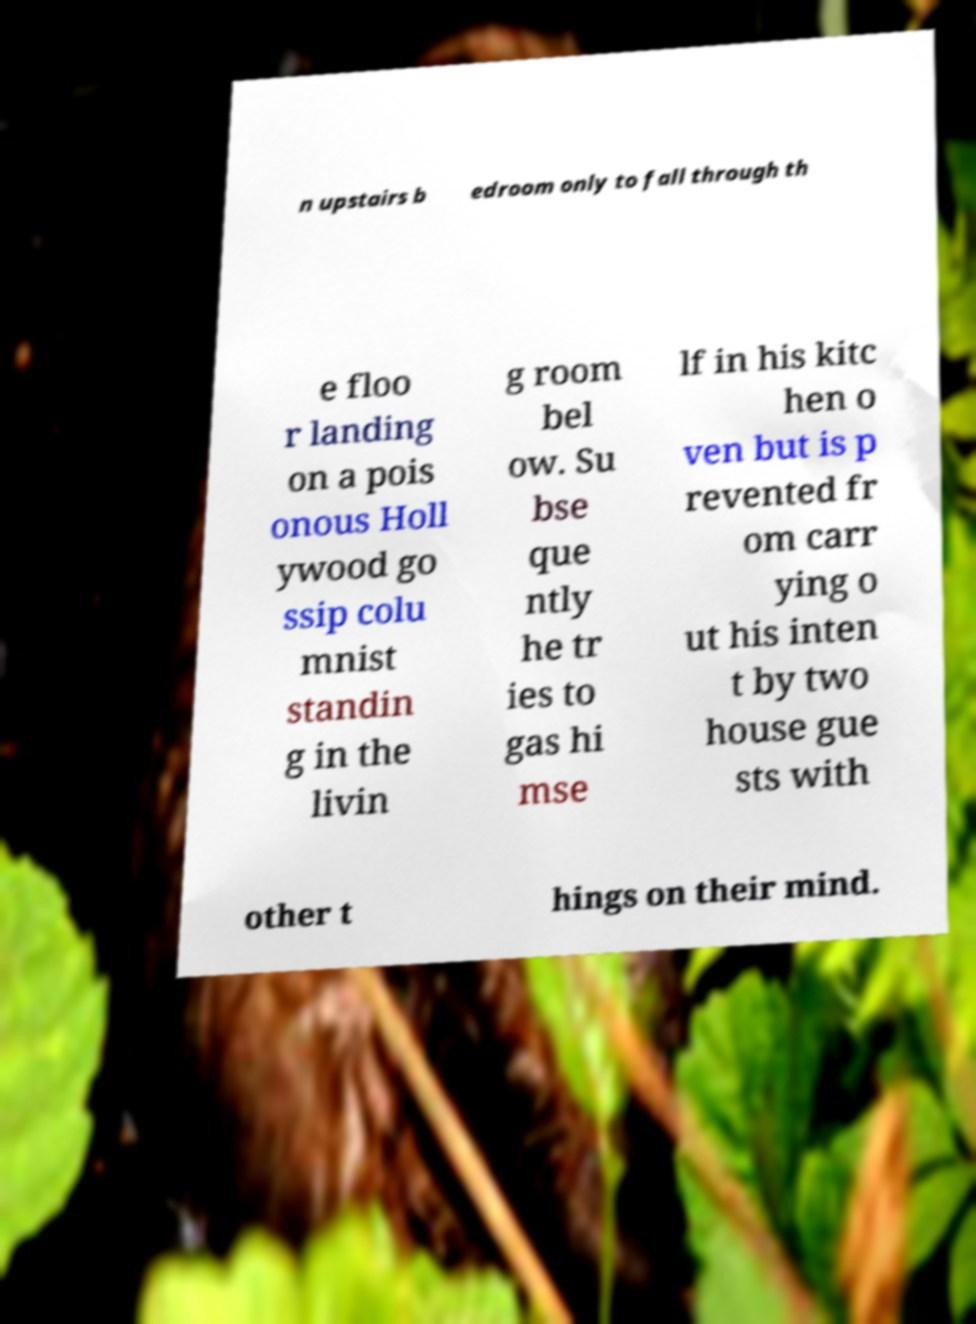Can you accurately transcribe the text from the provided image for me? n upstairs b edroom only to fall through th e floo r landing on a pois onous Holl ywood go ssip colu mnist standin g in the livin g room bel ow. Su bse que ntly he tr ies to gas hi mse lf in his kitc hen o ven but is p revented fr om carr ying o ut his inten t by two house gue sts with other t hings on their mind. 